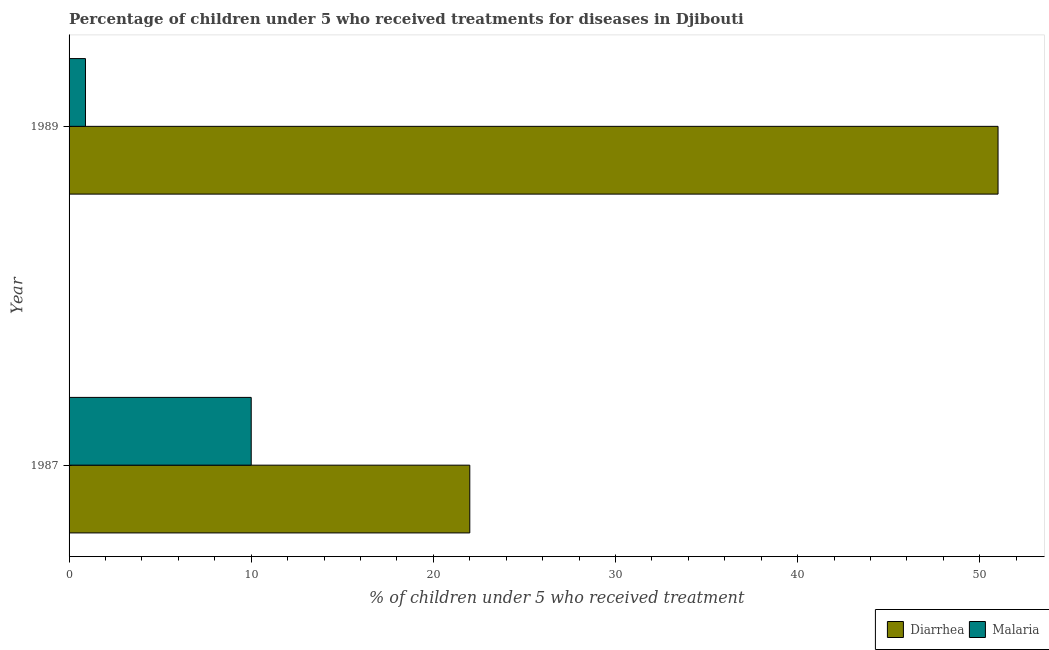Are the number of bars on each tick of the Y-axis equal?
Provide a short and direct response. Yes. How many bars are there on the 1st tick from the bottom?
Your answer should be compact. 2. Across all years, what is the maximum percentage of children who received treatment for diarrhoea?
Give a very brief answer. 51. Across all years, what is the minimum percentage of children who received treatment for diarrhoea?
Your response must be concise. 22. In which year was the percentage of children who received treatment for malaria minimum?
Provide a succinct answer. 1989. What is the total percentage of children who received treatment for diarrhoea in the graph?
Your answer should be compact. 73. What is the difference between the percentage of children who received treatment for malaria in 1987 and that in 1989?
Your answer should be compact. 9.1. What is the difference between the percentage of children who received treatment for malaria in 1987 and the percentage of children who received treatment for diarrhoea in 1989?
Your answer should be very brief. -41. What is the average percentage of children who received treatment for diarrhoea per year?
Your response must be concise. 36.5. In the year 1989, what is the difference between the percentage of children who received treatment for diarrhoea and percentage of children who received treatment for malaria?
Give a very brief answer. 50.1. What is the ratio of the percentage of children who received treatment for malaria in 1987 to that in 1989?
Your answer should be compact. 11.11. Is the difference between the percentage of children who received treatment for malaria in 1987 and 1989 greater than the difference between the percentage of children who received treatment for diarrhoea in 1987 and 1989?
Keep it short and to the point. Yes. What does the 1st bar from the top in 1987 represents?
Ensure brevity in your answer.  Malaria. What does the 2nd bar from the bottom in 1989 represents?
Provide a short and direct response. Malaria. How many bars are there?
Keep it short and to the point. 4. How many years are there in the graph?
Offer a very short reply. 2. Does the graph contain any zero values?
Provide a succinct answer. No. Where does the legend appear in the graph?
Ensure brevity in your answer.  Bottom right. How are the legend labels stacked?
Your answer should be very brief. Horizontal. What is the title of the graph?
Offer a terse response. Percentage of children under 5 who received treatments for diseases in Djibouti. What is the label or title of the X-axis?
Keep it short and to the point. % of children under 5 who received treatment. What is the % of children under 5 who received treatment in Diarrhea in 1989?
Provide a succinct answer. 51. Across all years, what is the minimum % of children under 5 who received treatment in Diarrhea?
Give a very brief answer. 22. Across all years, what is the minimum % of children under 5 who received treatment in Malaria?
Keep it short and to the point. 0.9. What is the total % of children under 5 who received treatment of Diarrhea in the graph?
Your answer should be very brief. 73. What is the difference between the % of children under 5 who received treatment of Malaria in 1987 and that in 1989?
Offer a terse response. 9.1. What is the difference between the % of children under 5 who received treatment of Diarrhea in 1987 and the % of children under 5 who received treatment of Malaria in 1989?
Ensure brevity in your answer.  21.1. What is the average % of children under 5 who received treatment of Diarrhea per year?
Your response must be concise. 36.5. What is the average % of children under 5 who received treatment in Malaria per year?
Your answer should be very brief. 5.45. In the year 1987, what is the difference between the % of children under 5 who received treatment of Diarrhea and % of children under 5 who received treatment of Malaria?
Offer a very short reply. 12. In the year 1989, what is the difference between the % of children under 5 who received treatment in Diarrhea and % of children under 5 who received treatment in Malaria?
Provide a succinct answer. 50.1. What is the ratio of the % of children under 5 who received treatment in Diarrhea in 1987 to that in 1989?
Make the answer very short. 0.43. What is the ratio of the % of children under 5 who received treatment in Malaria in 1987 to that in 1989?
Your answer should be very brief. 11.11. What is the difference between the highest and the second highest % of children under 5 who received treatment of Malaria?
Keep it short and to the point. 9.1. 